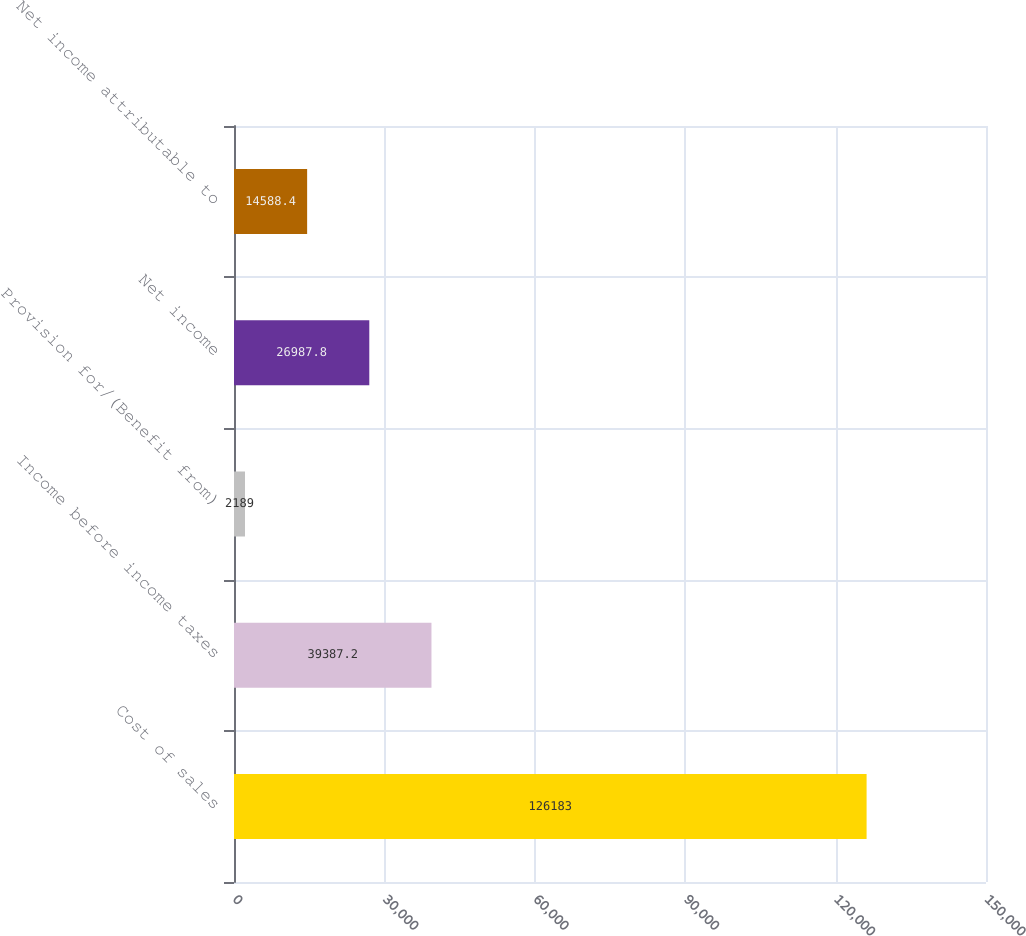Convert chart to OTSL. <chart><loc_0><loc_0><loc_500><loc_500><bar_chart><fcel>Cost of sales<fcel>Income before income taxes<fcel>Provision for/(Benefit from)<fcel>Net income<fcel>Net income attributable to<nl><fcel>126183<fcel>39387.2<fcel>2189<fcel>26987.8<fcel>14588.4<nl></chart> 